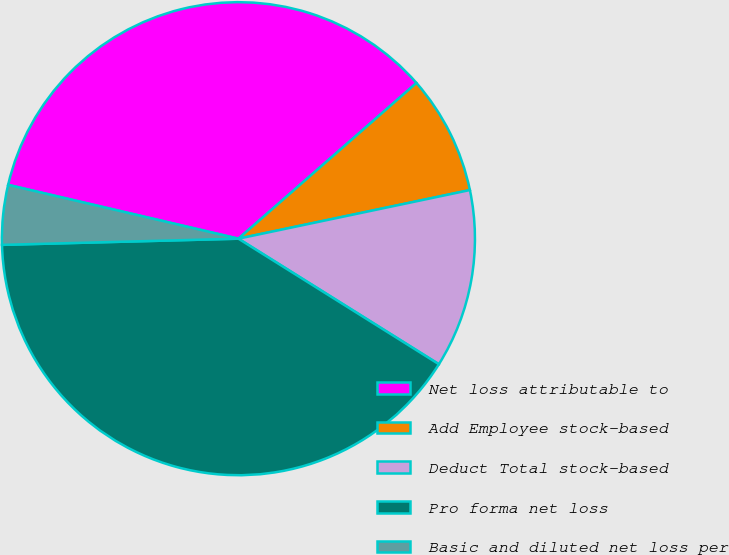<chart> <loc_0><loc_0><loc_500><loc_500><pie_chart><fcel>Net loss attributable to<fcel>Add Employee stock-based<fcel>Deduct Total stock-based<fcel>Pro forma net loss<fcel>Basic and diluted net loss per<nl><fcel>34.91%<fcel>8.14%<fcel>12.2%<fcel>40.68%<fcel>4.07%<nl></chart> 